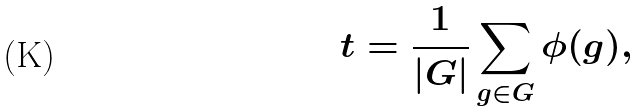<formula> <loc_0><loc_0><loc_500><loc_500>t = \frac { 1 } { | G | } \sum _ { g \in G } \phi ( g ) ,</formula> 